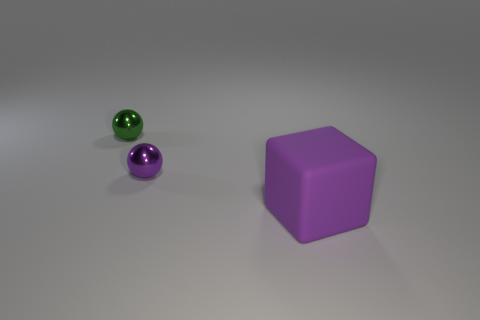What size is the purple thing that is in front of the purple object behind the big purple block? The purple object in front of the larger purple object, which is behind the big purple block, is relatively small in size, resembling a standard-sized marble or bead. 